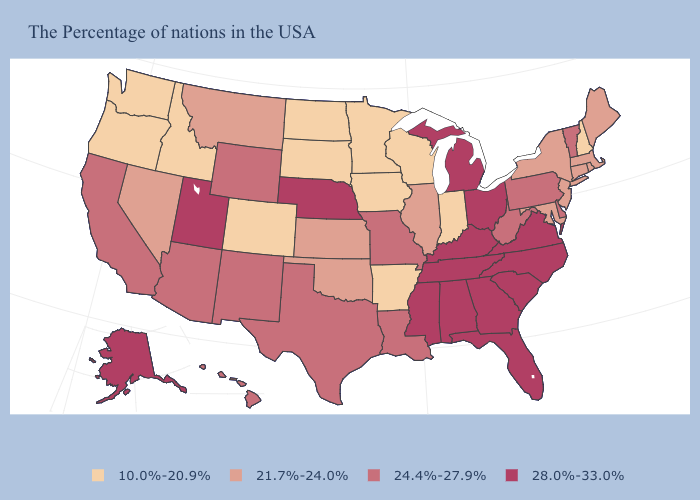What is the value of Alabama?
Concise answer only. 28.0%-33.0%. Name the states that have a value in the range 28.0%-33.0%?
Give a very brief answer. Virginia, North Carolina, South Carolina, Ohio, Florida, Georgia, Michigan, Kentucky, Alabama, Tennessee, Mississippi, Nebraska, Utah, Alaska. Does the first symbol in the legend represent the smallest category?
Give a very brief answer. Yes. Name the states that have a value in the range 24.4%-27.9%?
Quick response, please. Vermont, Delaware, Pennsylvania, West Virginia, Louisiana, Missouri, Texas, Wyoming, New Mexico, Arizona, California, Hawaii. What is the value of Oklahoma?
Write a very short answer. 21.7%-24.0%. What is the value of South Carolina?
Be succinct. 28.0%-33.0%. How many symbols are there in the legend?
Short answer required. 4. What is the highest value in the USA?
Short answer required. 28.0%-33.0%. What is the value of Arizona?
Quick response, please. 24.4%-27.9%. Among the states that border Idaho , which have the lowest value?
Give a very brief answer. Washington, Oregon. What is the value of Washington?
Concise answer only. 10.0%-20.9%. Name the states that have a value in the range 21.7%-24.0%?
Be succinct. Maine, Massachusetts, Rhode Island, Connecticut, New York, New Jersey, Maryland, Illinois, Kansas, Oklahoma, Montana, Nevada. Which states hav the highest value in the Northeast?
Be succinct. Vermont, Pennsylvania. 